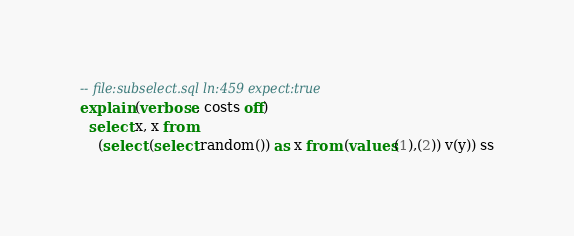<code> <loc_0><loc_0><loc_500><loc_500><_SQL_>-- file:subselect.sql ln:459 expect:true
explain (verbose, costs off)
  select x, x from
    (select (select random()) as x from (values(1),(2)) v(y)) ss
</code> 